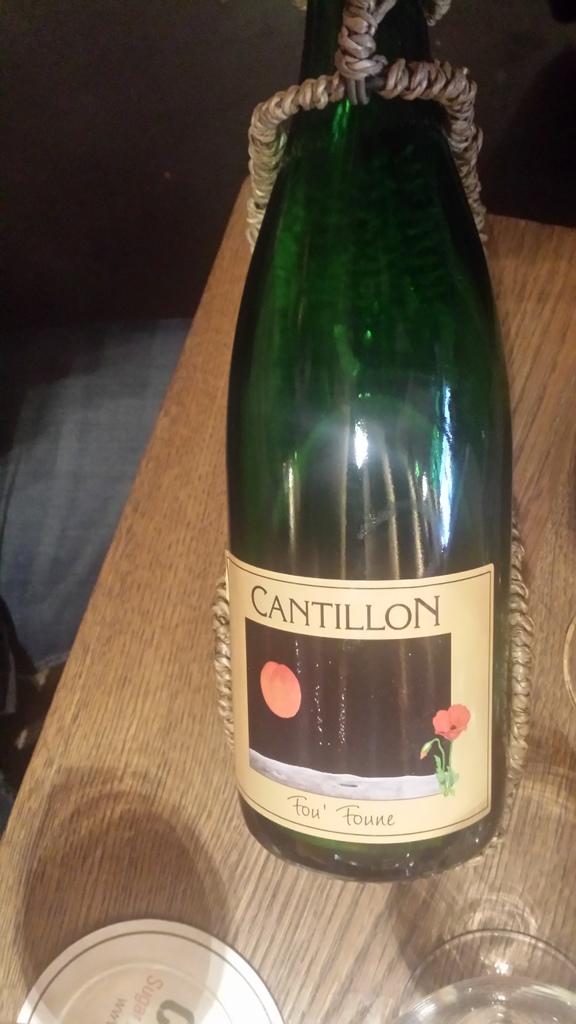Who makes this brand of wine?
Offer a terse response. Cantillon. What is this flavor of wine?
Ensure brevity in your answer.  Fou foune. 